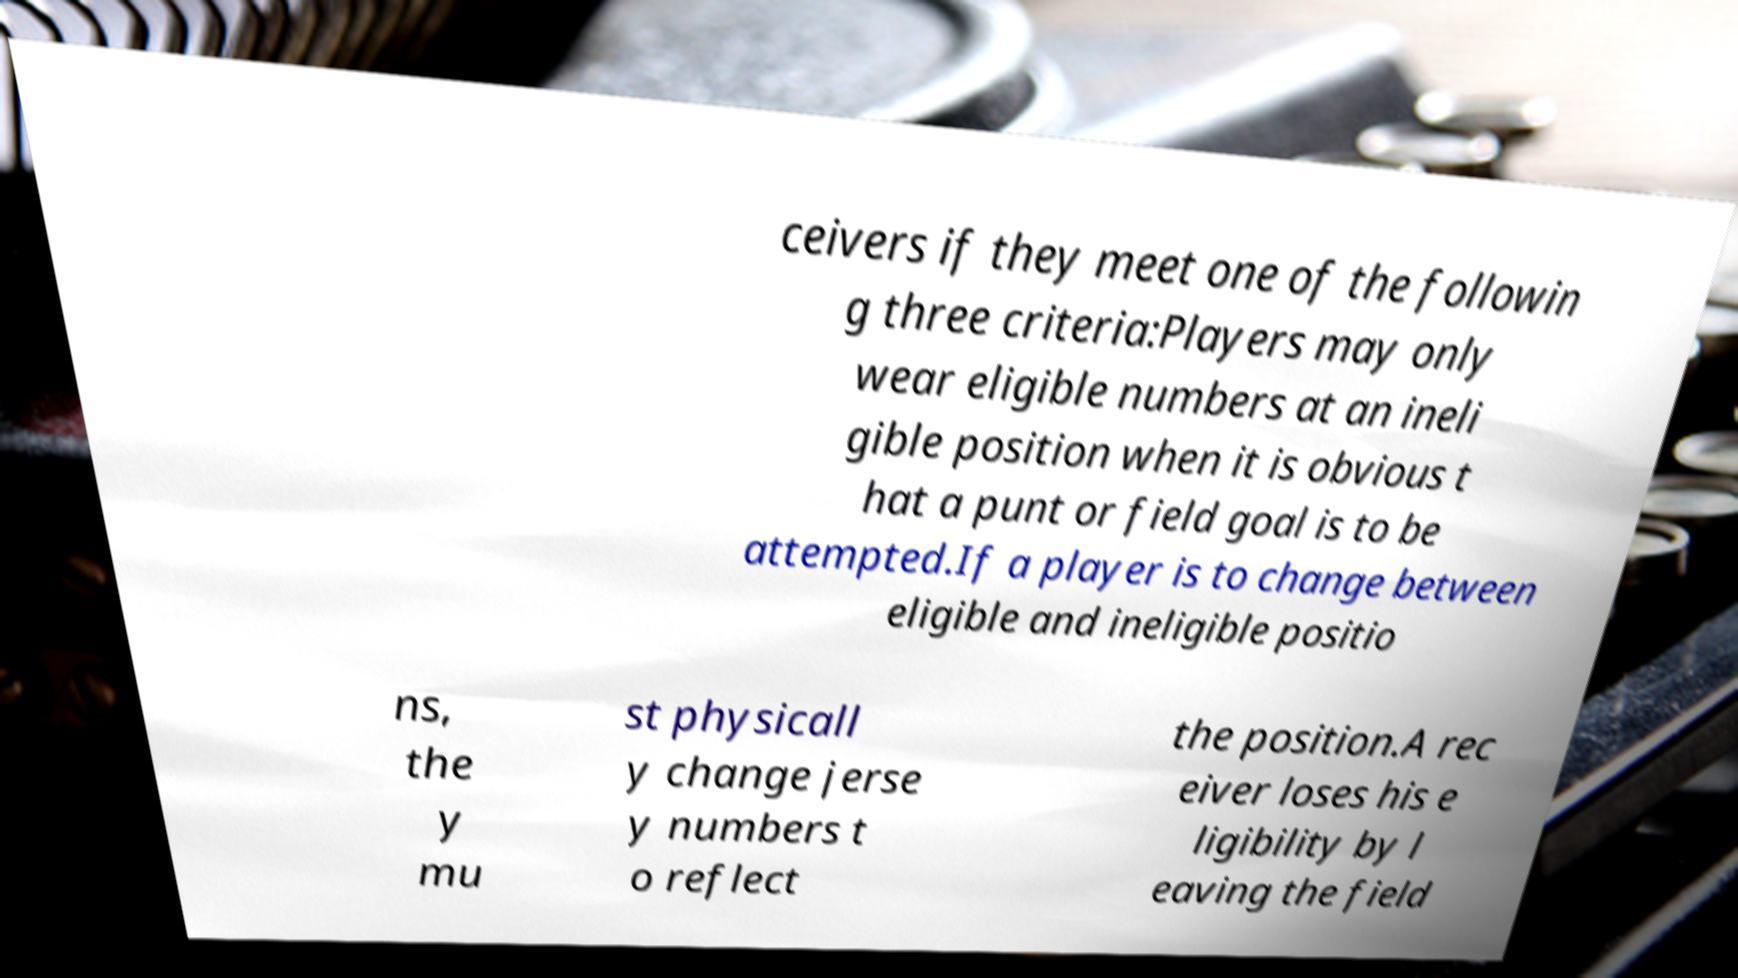Please read and relay the text visible in this image. What does it say? ceivers if they meet one of the followin g three criteria:Players may only wear eligible numbers at an ineli gible position when it is obvious t hat a punt or field goal is to be attempted.If a player is to change between eligible and ineligible positio ns, the y mu st physicall y change jerse y numbers t o reflect the position.A rec eiver loses his e ligibility by l eaving the field 